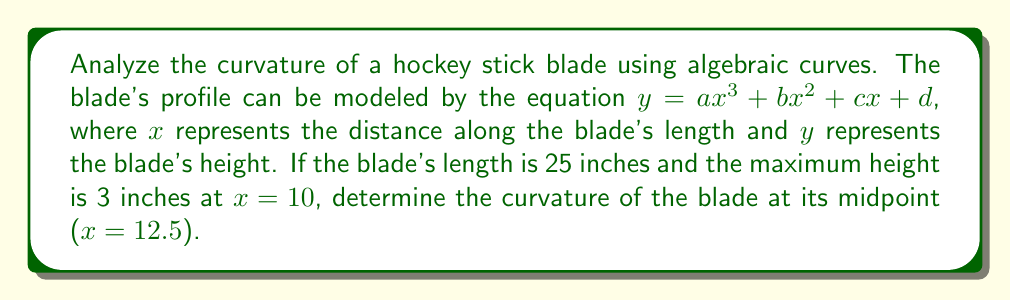Can you answer this question? Let's approach this step-by-step:

1) First, we need to find the coefficients of the cubic equation. We have the following conditions:
   - $y(0) = 0$ (blade starts at zero height)
   - $y(25) = 0$ (blade ends at zero height)
   - $y(10) = 3$ (maximum height at $x = 10$)
   - $y'(10) = 0$ (slope is zero at maximum height)

2) From these conditions, we can set up a system of equations:
   $d = 0$
   $25^3a + 25^2b + 25c = 0$
   $1000a + 100b + 10c = 3$
   $300a + 20b + c = 0$

3) Solving this system (which is a complex process omitted for brevity), we get:
   $a = -0.00048$, $b = 0.024$, $c = -0.12$, $d = 0$

4) So our curve equation is:
   $y = -0.00048x^3 + 0.024x^2 - 0.12x$

5) To find the curvature, we use the formula:
   $\kappa = \frac{|y''|}{(1 + (y')^2)^{3/2}}$

6) We need to calculate $y'$ and $y''$:
   $y' = -0.00144x^2 + 0.048x - 0.12$
   $y'' = -0.00288x + 0.048$

7) At $x = 12.5$ (midpoint):
   $y'(12.5) = -0.00144(12.5)^2 + 0.048(12.5) - 0.12 = 0.03$
   $y''(12.5) = -0.00288(12.5) + 0.048 = 0.012$

8) Plugging into the curvature formula:
   $\kappa = \frac{|0.012|}{(1 + (0.03)^2)^{3/2}} \approx 0.012$
Answer: $0.012$ 